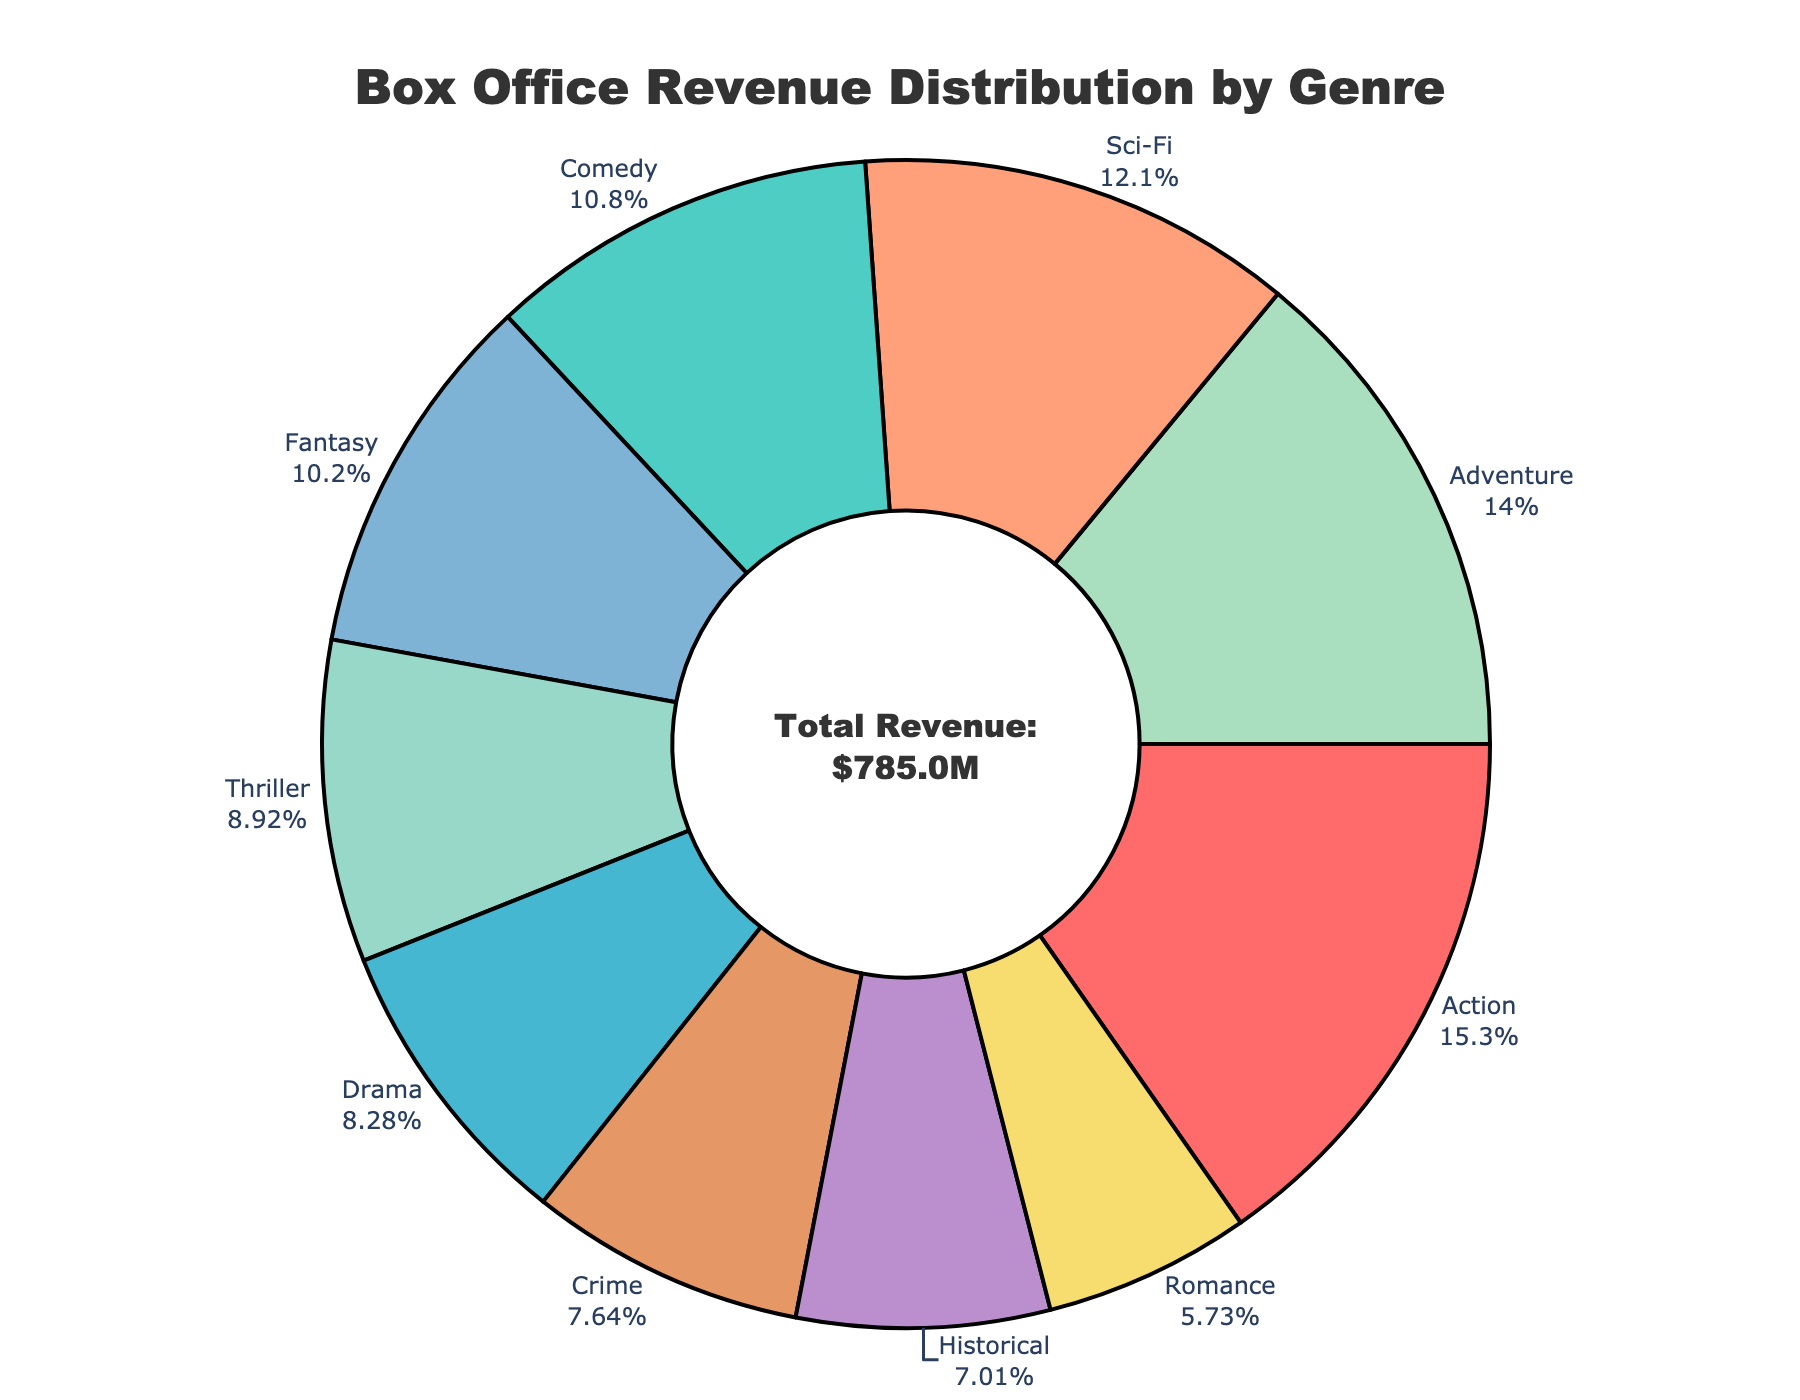What percentage of the total revenue does the Action genre contribute? Looking at the pie chart, the Action genre slice will have a percentage label outside of it. This percentage shows the contribution of the Action genre to the total revenue.
Answer: 21.1% Which genre has the smallest share of the total box office revenue? By observing the size of each slice in the pie, the smallest slice represents the genre with the smallest share. The Romance genre seems to be the smallest slice.
Answer: Romance By how much does the Adventure genre's revenue exceed the Crime genre's revenue? First, identify the revenue amounts for both Adventure ($110M) and Crime ($60M) from the hover information or labels. Then, subtract the Crime revenue from the Adventure revenue. $110M - $60M = $50M.
Answer: $50M Which genres collectively cover more than 50% of the box office revenue? By summing the percentages of descending order slices until surpassing 50%, we get the genres Action (21.1%), Sci-Fi (16.7%), and Adventure (19.4%). These three genres collectively total 57.2%.
Answer: Action, Sci-Fi, Adventure How does the revenue from Fantasy compare to that from Comedy? Locate the pie slices for Fantasy and Comedy. The Fantasy revenue is $80M, and the Comedy revenue is $85M as shown in hover information or labels. Recognition of slightly larger Comedy slice verifies Comedy earning more.
Answer: Comedy What's the total revenue generated by Drama, Thriller, and Romance genres? Extract individual revenues: Drama ($65M), Thriller ($70M), and Romance ($45M). Summing these, $65M + $70M + $45M = $180M.
Answer: $180M Which genre slice is colored red? The pie chart visual indicates that the Action genre slice is colored red, identifiable by simply observing the pie chart colors.
Answer: Action What is the revenue difference between the highest and lowest revenue genres? Identify highest (Action - $120M) and lowest (Romance - $45M) revenue genres from hover info/labels. Calculate difference $120M - $45M = $75M.
Answer: $75M How do Historical and Fantasy genres' revenue totals compare? Extract revenues: Historical ($55M) and Fantasy ($80M). Calculate difference: $80M - $55M = $25M indicating Fantasy has $25M more than Historical.
Answer: Fantasy by $25M 